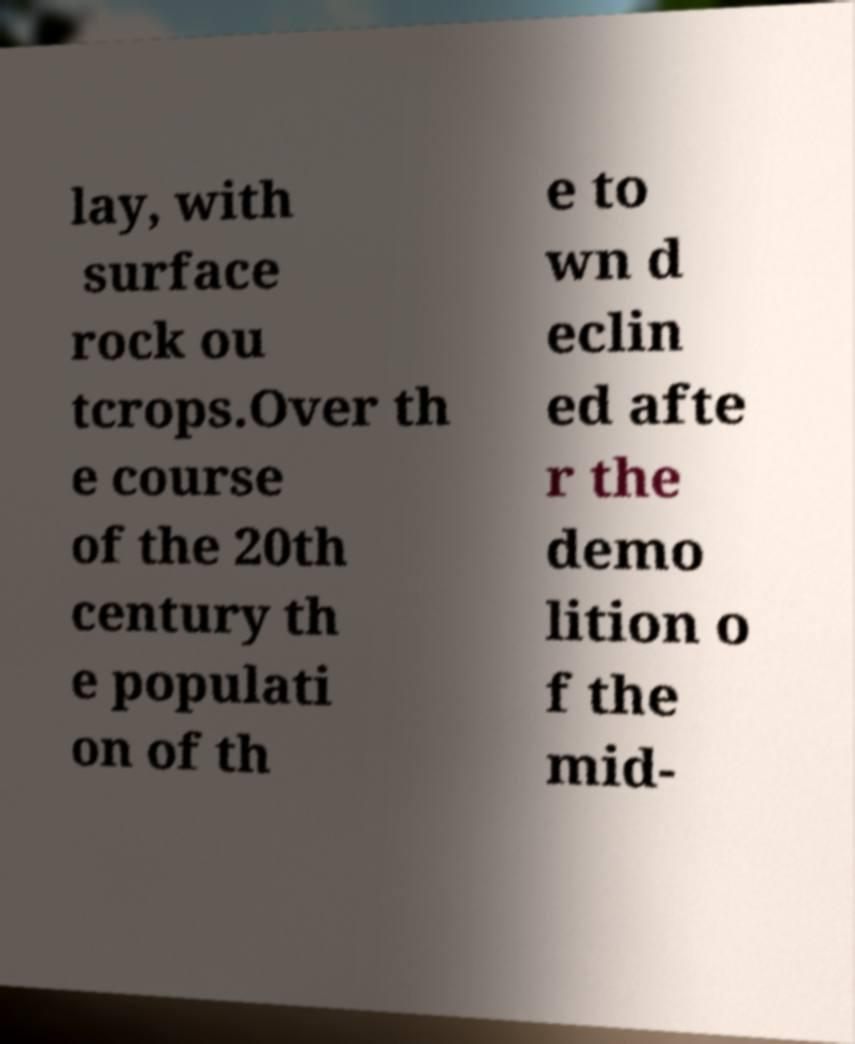Can you accurately transcribe the text from the provided image for me? lay, with surface rock ou tcrops.Over th e course of the 20th century th e populati on of th e to wn d eclin ed afte r the demo lition o f the mid- 